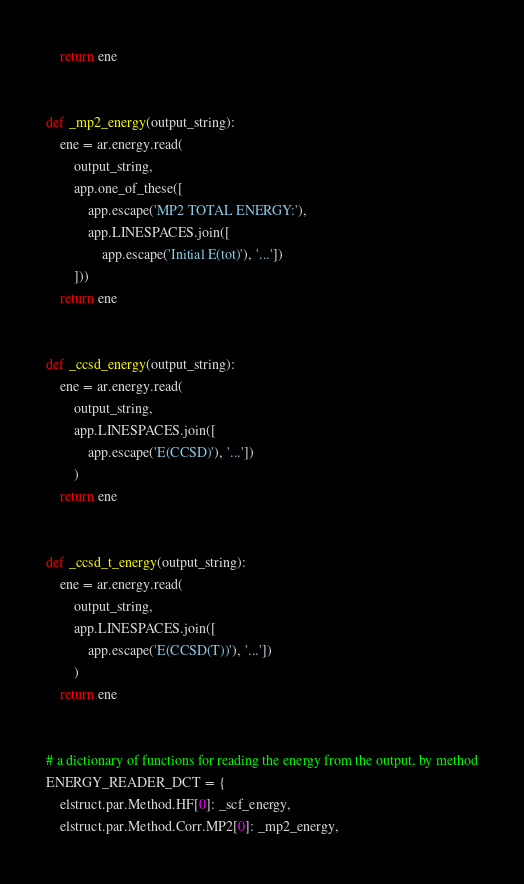<code> <loc_0><loc_0><loc_500><loc_500><_Python_>    return ene


def _mp2_energy(output_string):
    ene = ar.energy.read(
        output_string,
        app.one_of_these([
            app.escape('MP2 TOTAL ENERGY:'),
            app.LINESPACES.join([
                app.escape('Initial E(tot)'), '...'])
        ]))
    return ene


def _ccsd_energy(output_string):
    ene = ar.energy.read(
        output_string,
        app.LINESPACES.join([
            app.escape('E(CCSD)'), '...'])
        )
    return ene


def _ccsd_t_energy(output_string):
    ene = ar.energy.read(
        output_string,
        app.LINESPACES.join([
            app.escape('E(CCSD(T))'), '...'])
        )
    return ene


# a dictionary of functions for reading the energy from the output, by method
ENERGY_READER_DCT = {
    elstruct.par.Method.HF[0]: _scf_energy,
    elstruct.par.Method.Corr.MP2[0]: _mp2_energy,</code> 